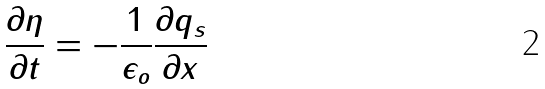Convert formula to latex. <formula><loc_0><loc_0><loc_500><loc_500>\frac { \partial \eta } { \partial t } = - \frac { 1 } { \epsilon _ { o } } \frac { \partial q _ { s } } { \partial x }</formula> 